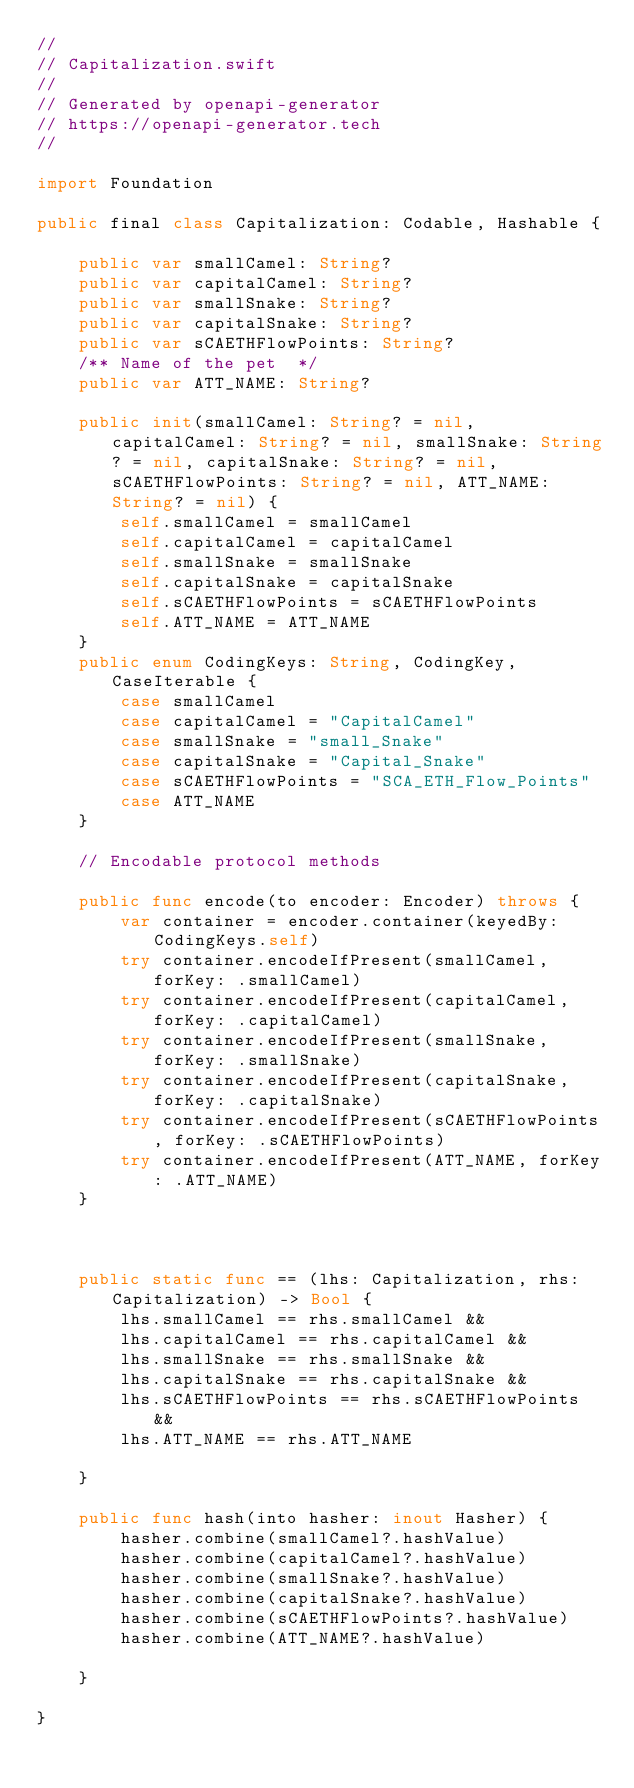Convert code to text. <code><loc_0><loc_0><loc_500><loc_500><_Swift_>//
// Capitalization.swift
//
// Generated by openapi-generator
// https://openapi-generator.tech
//

import Foundation

public final class Capitalization: Codable, Hashable {

    public var smallCamel: String?
    public var capitalCamel: String?
    public var smallSnake: String?
    public var capitalSnake: String?
    public var sCAETHFlowPoints: String?
    /** Name of the pet  */
    public var ATT_NAME: String?

    public init(smallCamel: String? = nil, capitalCamel: String? = nil, smallSnake: String? = nil, capitalSnake: String? = nil, sCAETHFlowPoints: String? = nil, ATT_NAME: String? = nil) {
        self.smallCamel = smallCamel
        self.capitalCamel = capitalCamel
        self.smallSnake = smallSnake
        self.capitalSnake = capitalSnake
        self.sCAETHFlowPoints = sCAETHFlowPoints
        self.ATT_NAME = ATT_NAME
    }
    public enum CodingKeys: String, CodingKey, CaseIterable {
        case smallCamel
        case capitalCamel = "CapitalCamel"
        case smallSnake = "small_Snake"
        case capitalSnake = "Capital_Snake"
        case sCAETHFlowPoints = "SCA_ETH_Flow_Points"
        case ATT_NAME
    }

    // Encodable protocol methods

    public func encode(to encoder: Encoder) throws {
        var container = encoder.container(keyedBy: CodingKeys.self)
        try container.encodeIfPresent(smallCamel, forKey: .smallCamel)
        try container.encodeIfPresent(capitalCamel, forKey: .capitalCamel)
        try container.encodeIfPresent(smallSnake, forKey: .smallSnake)
        try container.encodeIfPresent(capitalSnake, forKey: .capitalSnake)
        try container.encodeIfPresent(sCAETHFlowPoints, forKey: .sCAETHFlowPoints)
        try container.encodeIfPresent(ATT_NAME, forKey: .ATT_NAME)
    }



    public static func == (lhs: Capitalization, rhs: Capitalization) -> Bool {
        lhs.smallCamel == rhs.smallCamel &&
        lhs.capitalCamel == rhs.capitalCamel &&
        lhs.smallSnake == rhs.smallSnake &&
        lhs.capitalSnake == rhs.capitalSnake &&
        lhs.sCAETHFlowPoints == rhs.sCAETHFlowPoints &&
        lhs.ATT_NAME == rhs.ATT_NAME
        
    }

    public func hash(into hasher: inout Hasher) {
        hasher.combine(smallCamel?.hashValue)
        hasher.combine(capitalCamel?.hashValue)
        hasher.combine(smallSnake?.hashValue)
        hasher.combine(capitalSnake?.hashValue)
        hasher.combine(sCAETHFlowPoints?.hashValue)
        hasher.combine(ATT_NAME?.hashValue)
        
    }

}
</code> 